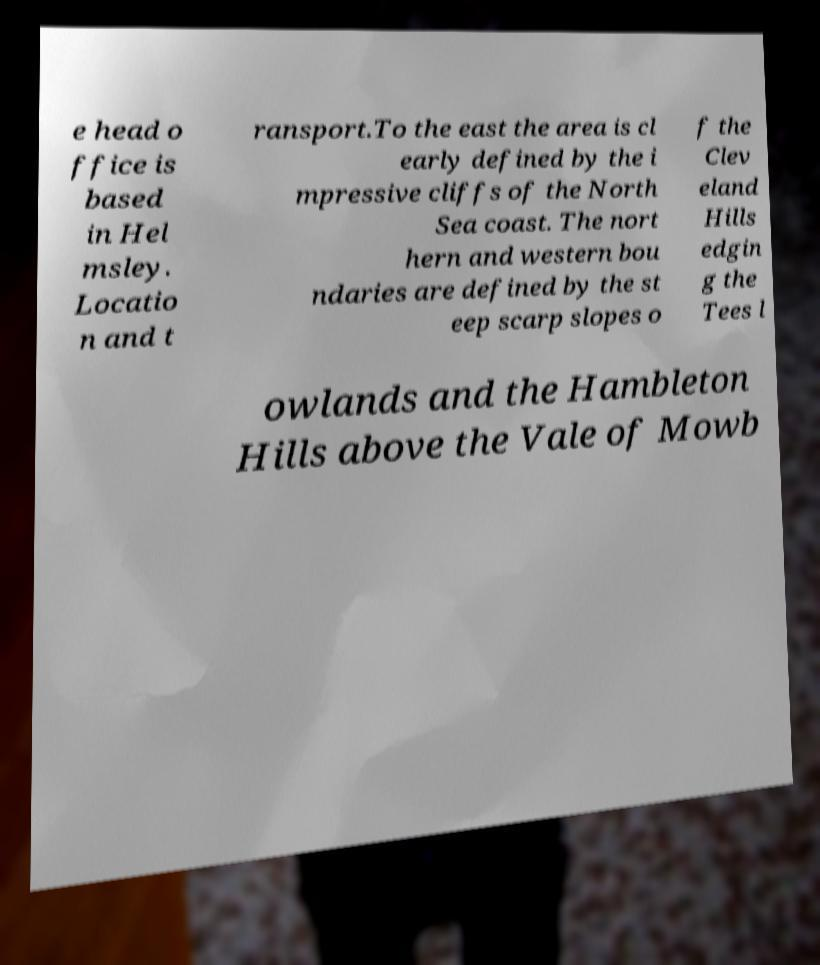Can you read and provide the text displayed in the image?This photo seems to have some interesting text. Can you extract and type it out for me? e head o ffice is based in Hel msley. Locatio n and t ransport.To the east the area is cl early defined by the i mpressive cliffs of the North Sea coast. The nort hern and western bou ndaries are defined by the st eep scarp slopes o f the Clev eland Hills edgin g the Tees l owlands and the Hambleton Hills above the Vale of Mowb 